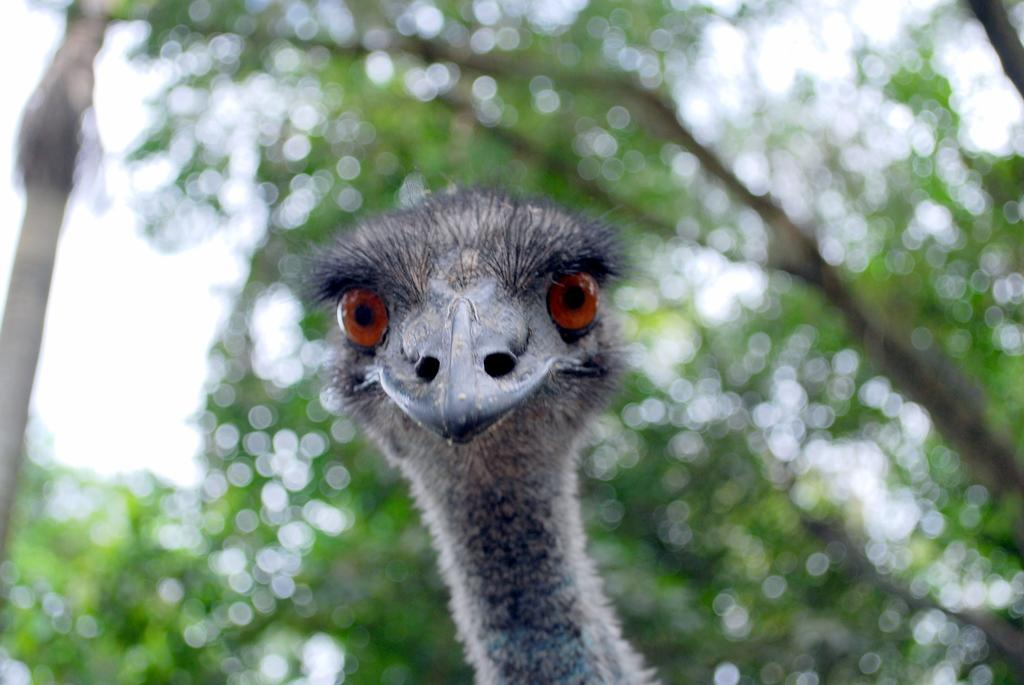What type of animal is the main subject of the image? There is an ostrich in the image. Can you describe the background of the image? The background of the image is blurred. What type of hospital is depicted in the background of the image? There is no hospital present in the image; the background is blurred. What type of rod can be seen in the image? There is no rod present in the image; it features an ostrich and a blurred background. 